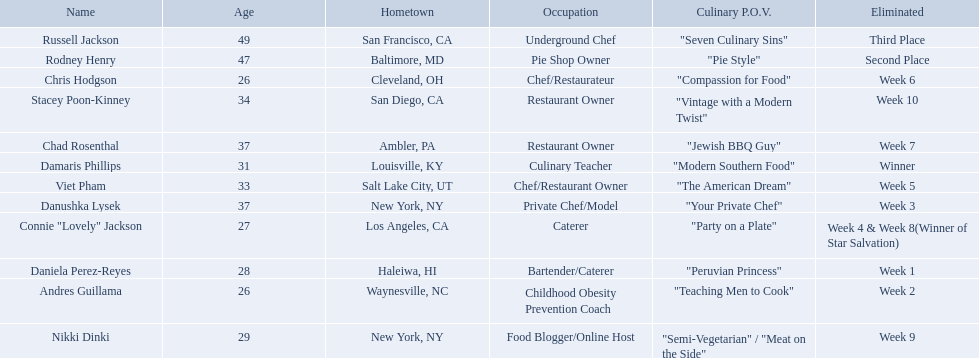Who are all of the contestants? Damaris Phillips, Rodney Henry, Russell Jackson, Stacey Poon-Kinney, Nikki Dinki, Chad Rosenthal, Chris Hodgson, Viet Pham, Connie "Lovely" Jackson, Danushka Lysek, Andres Guillama, Daniela Perez-Reyes. Which culinary p.o.v. is longer than vintage with a modern twist? "Semi-Vegetarian" / "Meat on the Side". Which contestant's p.o.v. is semi-vegetarian/meat on the side? Nikki Dinki. 